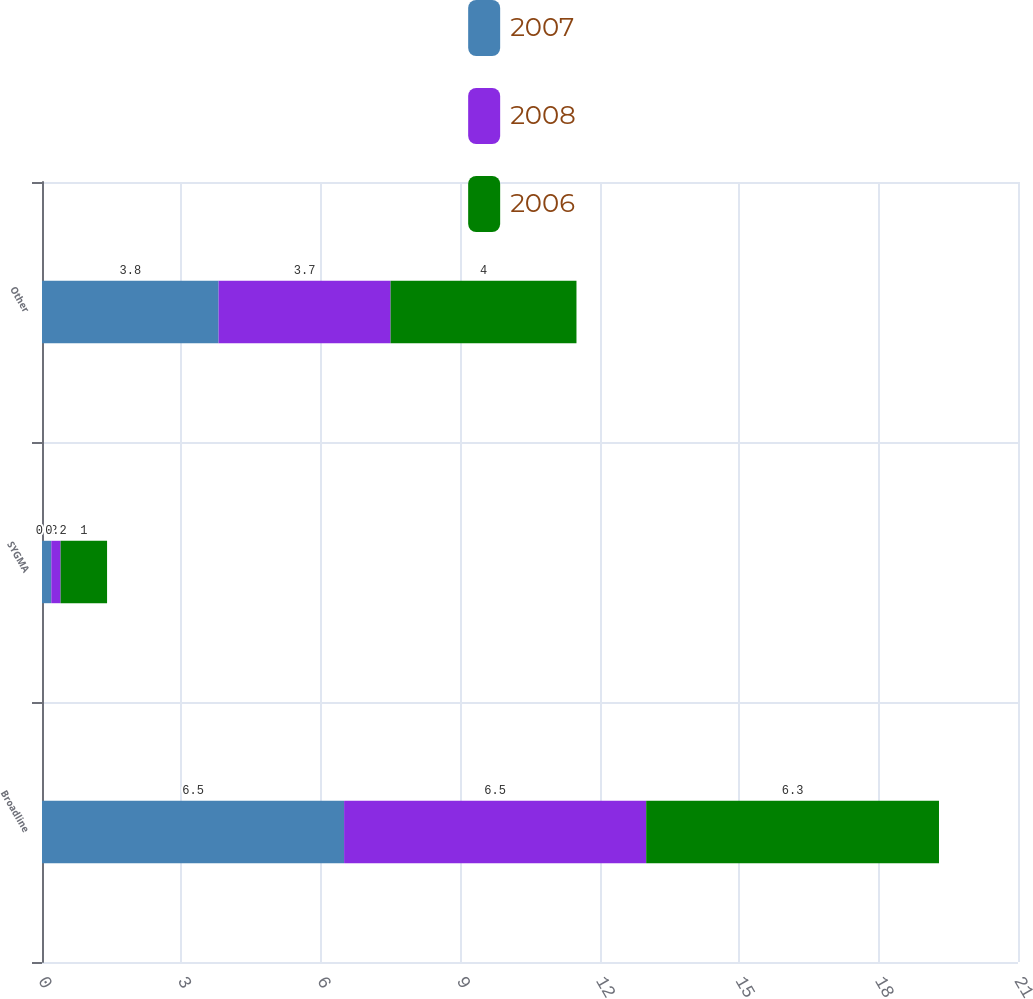Convert chart to OTSL. <chart><loc_0><loc_0><loc_500><loc_500><stacked_bar_chart><ecel><fcel>Broadline<fcel>SYGMA<fcel>Other<nl><fcel>2007<fcel>6.5<fcel>0.2<fcel>3.8<nl><fcel>2008<fcel>6.5<fcel>0.2<fcel>3.7<nl><fcel>2006<fcel>6.3<fcel>1<fcel>4<nl></chart> 